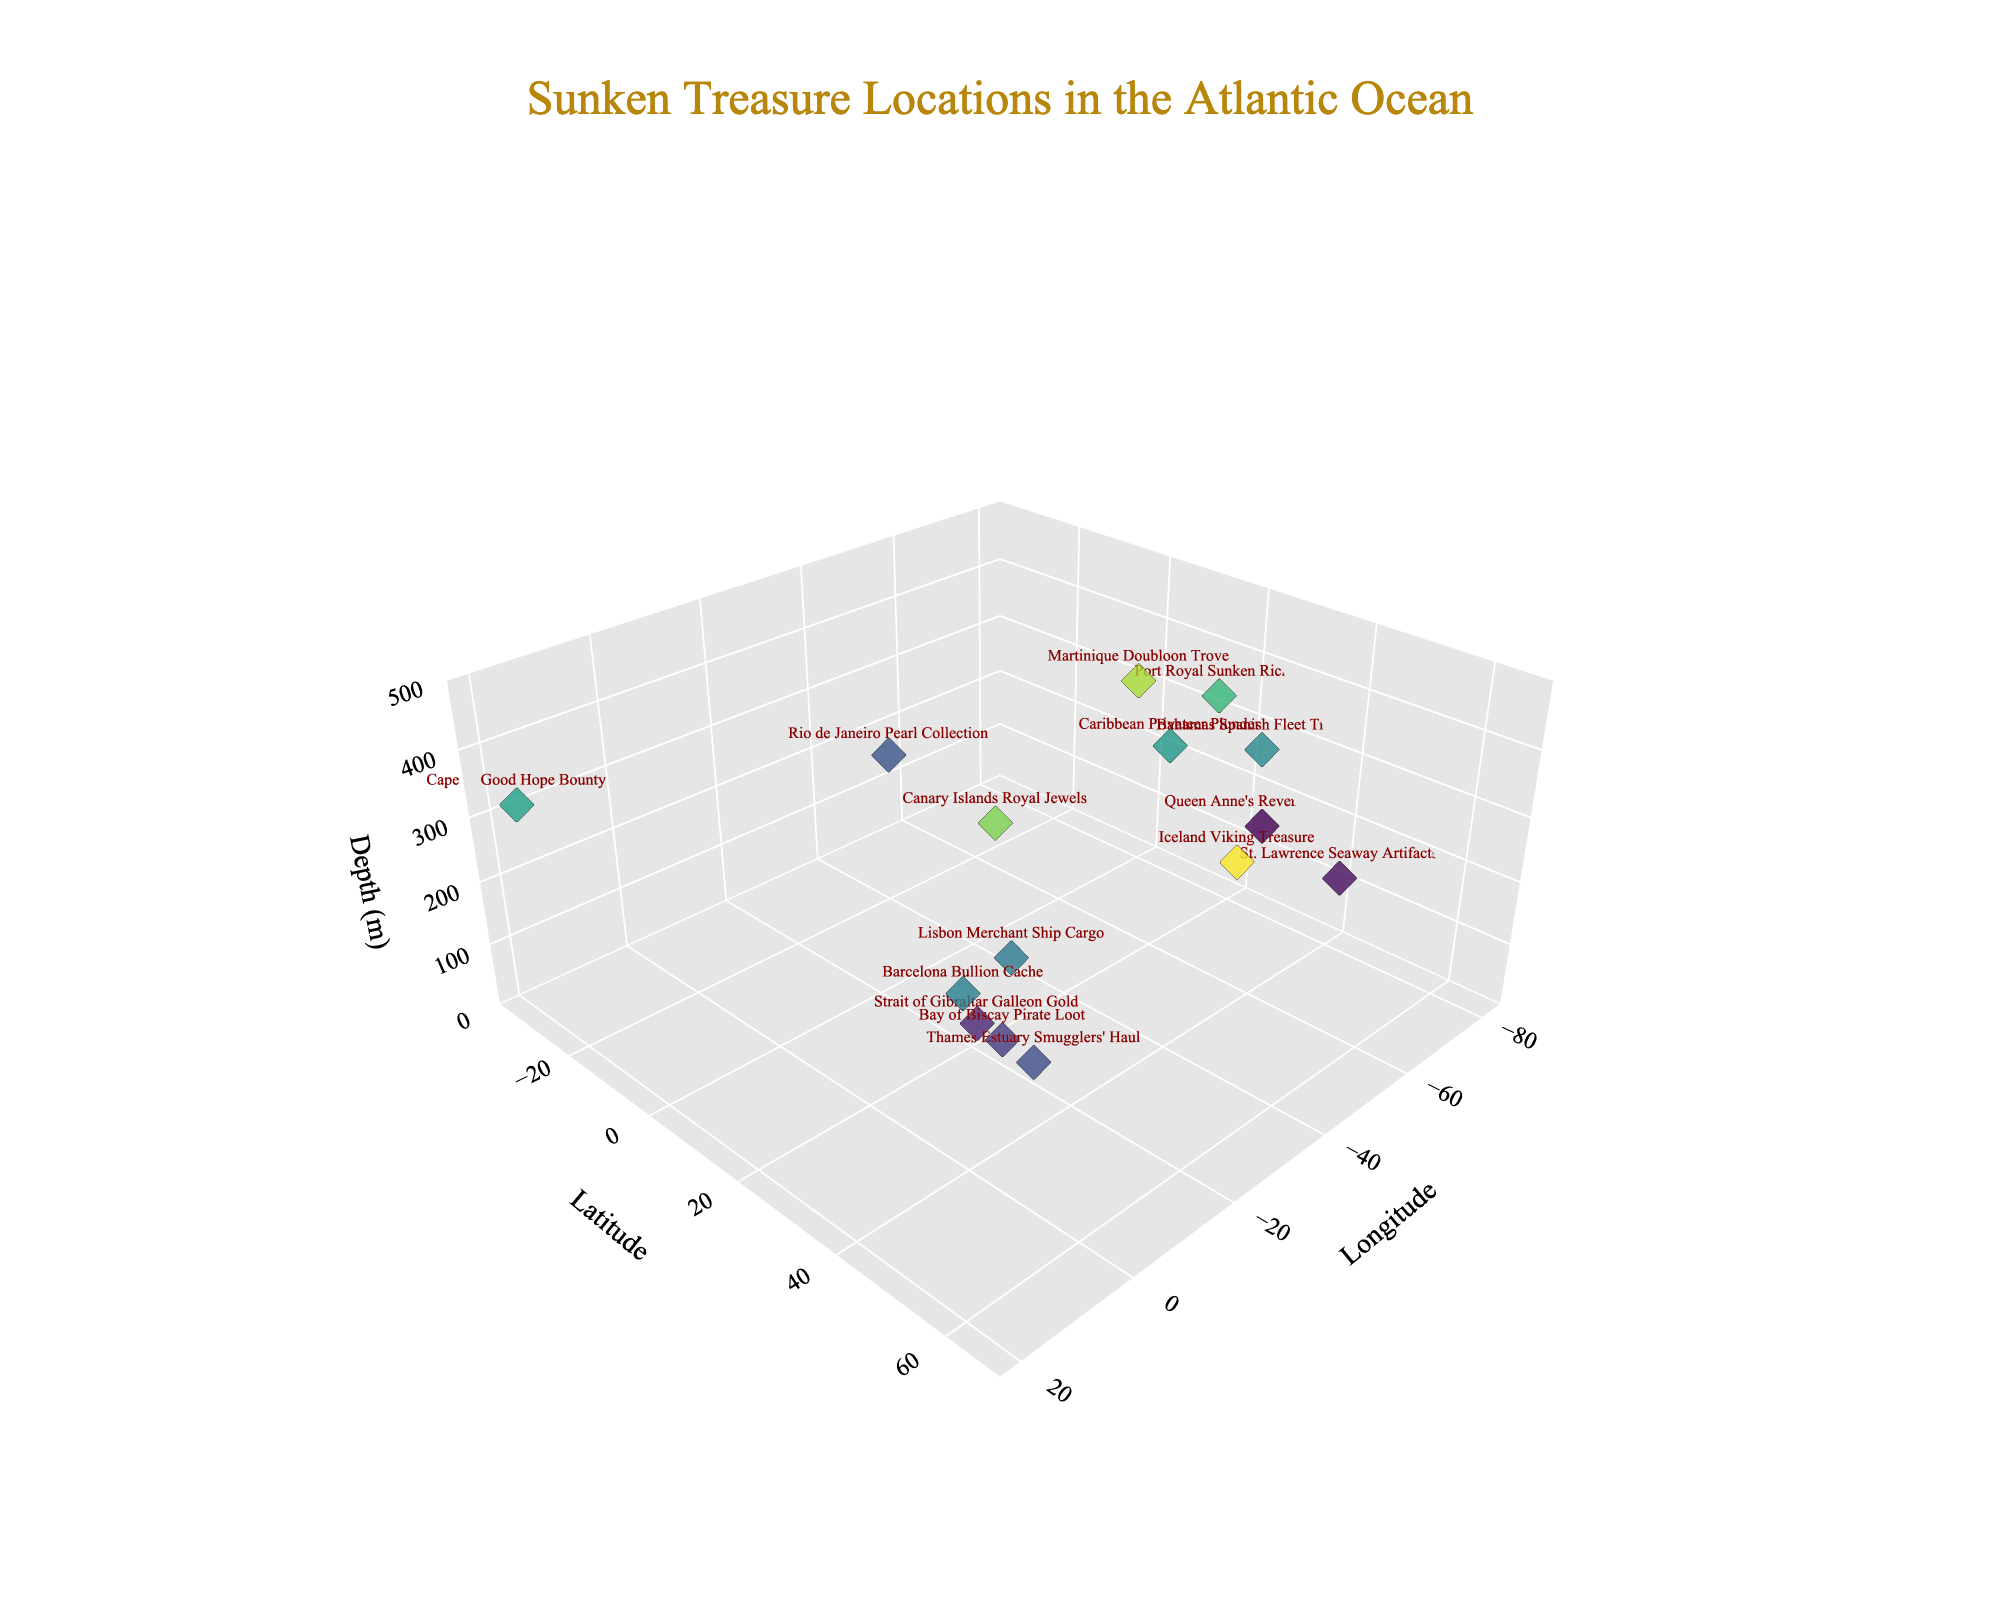what is the title of the plot? The title of the plot is typically displayed prominently at the top of the figure. In this case, it reads "Sunken Treasure Locations in the Atlantic Ocean".
Answer: Sunken Treasure Locations in the Atlantic Ocean What are the axes labels on the plot? The axes labels are usually located along each axis to define what the axis represents. In this figure, the x-axis is labeled as "Longitude", the y-axis as "Latitude", and the z-axis as "Depth (m)".
Answer: Longitude, Latitude, Depth (m) How many treasure locations are displayed in the plot? The number of treasure locations corresponds to the number of data points in the figure. By counting these, we find there are fifteen treasure locations displayed.
Answer: 15 Which treasure has the greatest depth? To determine the deepest treasure, we look for the data point with the highest depth value on the z-axis. The deepest treasure is "Iceland Viking Treasure" with a depth of 450 meters.
Answer: Iceland Viking Treasure What is the range for depth values in the plot? The range can be found by identifying the minimum and maximum depth values displayed. The shallowest treasure is at 150 meters, and the deepest is at 450 meters, so the range is 300 meters.
Answer: 150 meters to 450 meters Which locations have a depth greater than 300 meters? To find treasures deeper than 300 meters, we check the z-axis for depth values exceeding 300. These are "Martinique Doubloon Trove", "Port Royal Sunken Riches", "Canary Islands Royal Jewels", "Caribbean Privateer Plunder", and "Iceland Viking Treasure".
Answer: Martinique Doubloon Trove, Port Royal Sunken Riches, Canary Islands Royal Jewels, Caribbean Privateer Plunder, Iceland Viking Treasure Which treasure is at the shallowest depth? The treasure at the shallowest depth can be identified by looking for the data point with the lowest value on the z-axis. "Queen Anne's Revenge Hoard" is at 150 meters, the shalowest depth.
Answer: Queen Anne's Revenge Hoard What is the average depth of all treasure locations shown in the plot? To calculate the average depth, sum all depth values and divide by the total number of locations. Depths: 150+320+280+410+180+230+350+290+200+270+390+310+160+220+450. The sum is 4200 meters, divided by 15 equals 280 meters.
Answer: 280 meters How does the depth of "Bahamas Spanish Fleet Treasury" compare to "Barcelona Bullion Cache"? To compare depths, check the z-values for both treasures. "Bahamas Spanish Fleet Treasury" is at 290 meters, and "Barcelona Bullion Cache" is at 280 meters. Bahamas’ depth is 10 meters greater.
Answer: Bahamas Spanish Fleet Treasury is 10 meters deeper Are there any treasure locations grouped geographically close to each other? To determine geographical proximity, compare latitude and longitude values. For instance, "Queen Anne's Revenge Hoard" and "Bahamas Spanish Fleet Treasury" are geographically close with coordinates (25.7617, -80.1918) and (26.7153, -77.1867), respectively.
Answer: Queen Anne's Revenge Hoard and Bahamas Spanish Fleet Treasury 